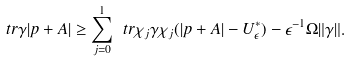Convert formula to latex. <formula><loc_0><loc_0><loc_500><loc_500>\ t r \gamma | p + A | \geq \sum _ { j = 0 } ^ { 1 } \ t r \chi _ { j } \gamma \chi _ { j } ( | p + A | - U _ { \epsilon } ^ { * } ) - \epsilon ^ { - 1 } \Omega \| \gamma \| .</formula> 